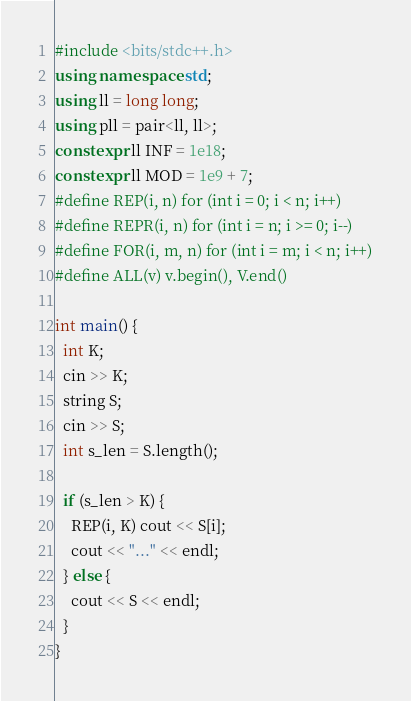Convert code to text. <code><loc_0><loc_0><loc_500><loc_500><_C++_>#include <bits/stdc++.h>
using namespace std;
using ll = long long;
using pll = pair<ll, ll>;
constexpr ll INF = 1e18;
constexpr ll MOD = 1e9 + 7;
#define REP(i, n) for (int i = 0; i < n; i++)
#define REPR(i, n) for (int i = n; i >= 0; i--)
#define FOR(i, m, n) for (int i = m; i < n; i++)
#define ALL(v) v.begin(), V.end()

int main() {
  int K;
  cin >> K;
  string S;
  cin >> S;
  int s_len = S.length();

  if (s_len > K) {
    REP(i, K) cout << S[i];
    cout << "..." << endl;
  } else {
    cout << S << endl;
  }
}</code> 